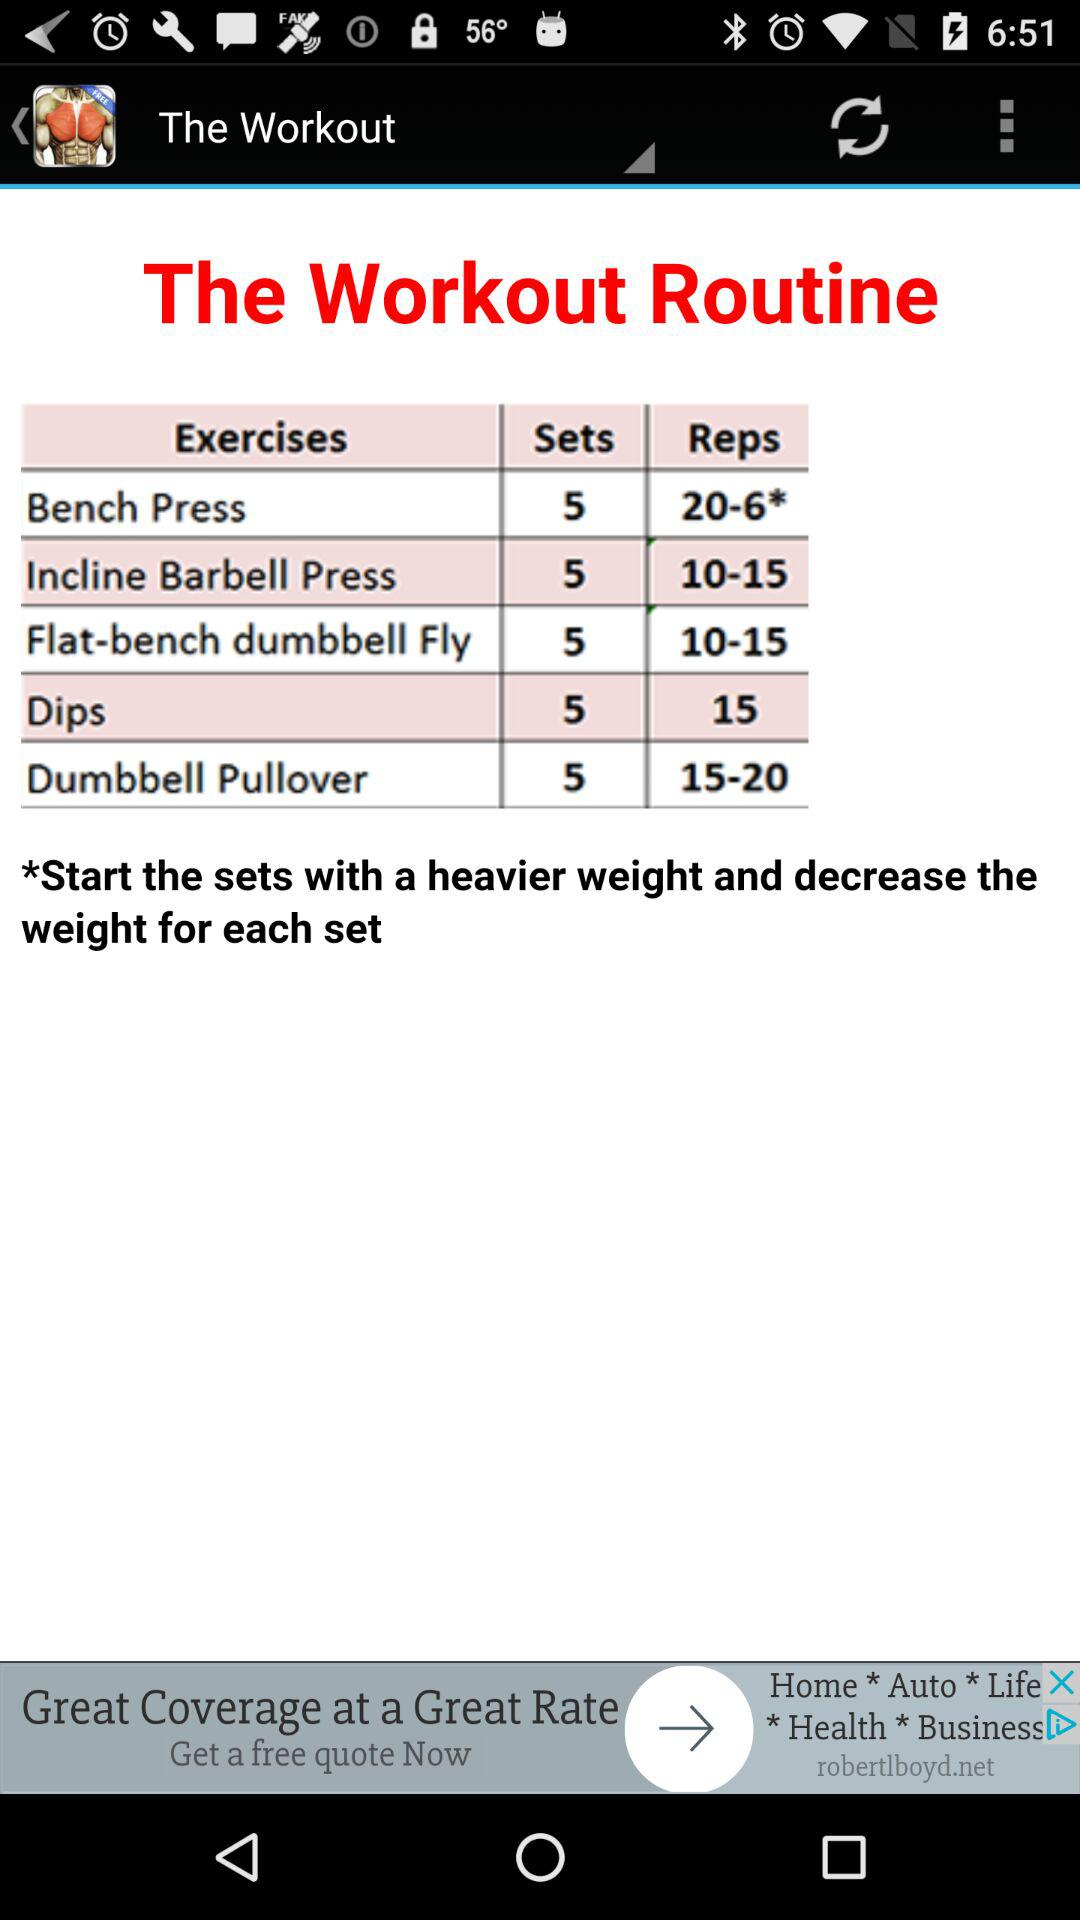How many sets should a bench press have? A bench press should have 5 sets. 